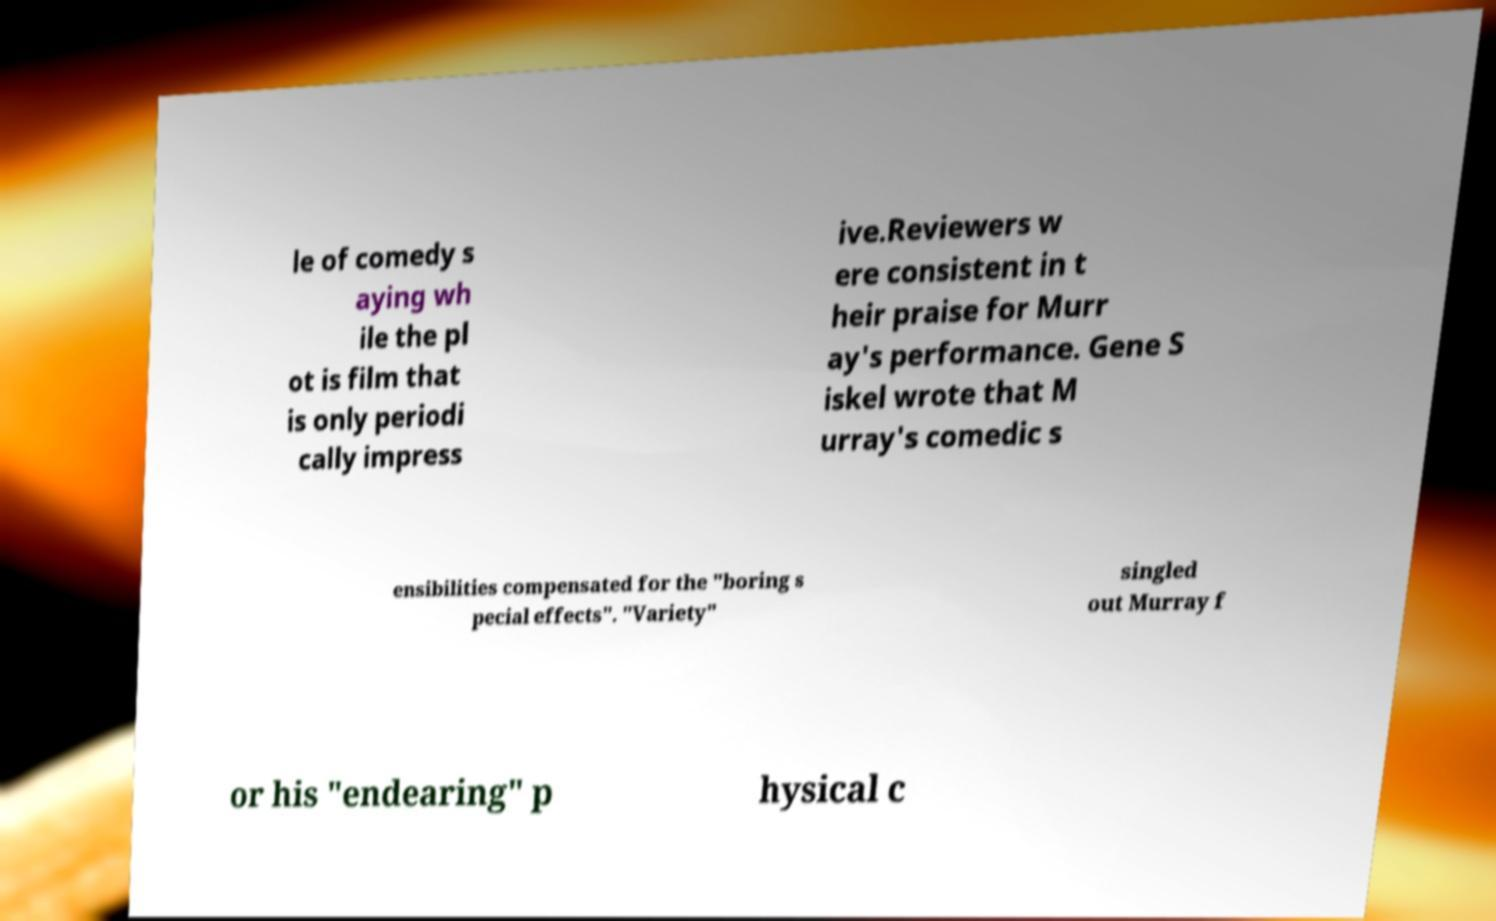For documentation purposes, I need the text within this image transcribed. Could you provide that? le of comedy s aying wh ile the pl ot is film that is only periodi cally impress ive.Reviewers w ere consistent in t heir praise for Murr ay's performance. Gene S iskel wrote that M urray's comedic s ensibilities compensated for the "boring s pecial effects". "Variety" singled out Murray f or his "endearing" p hysical c 